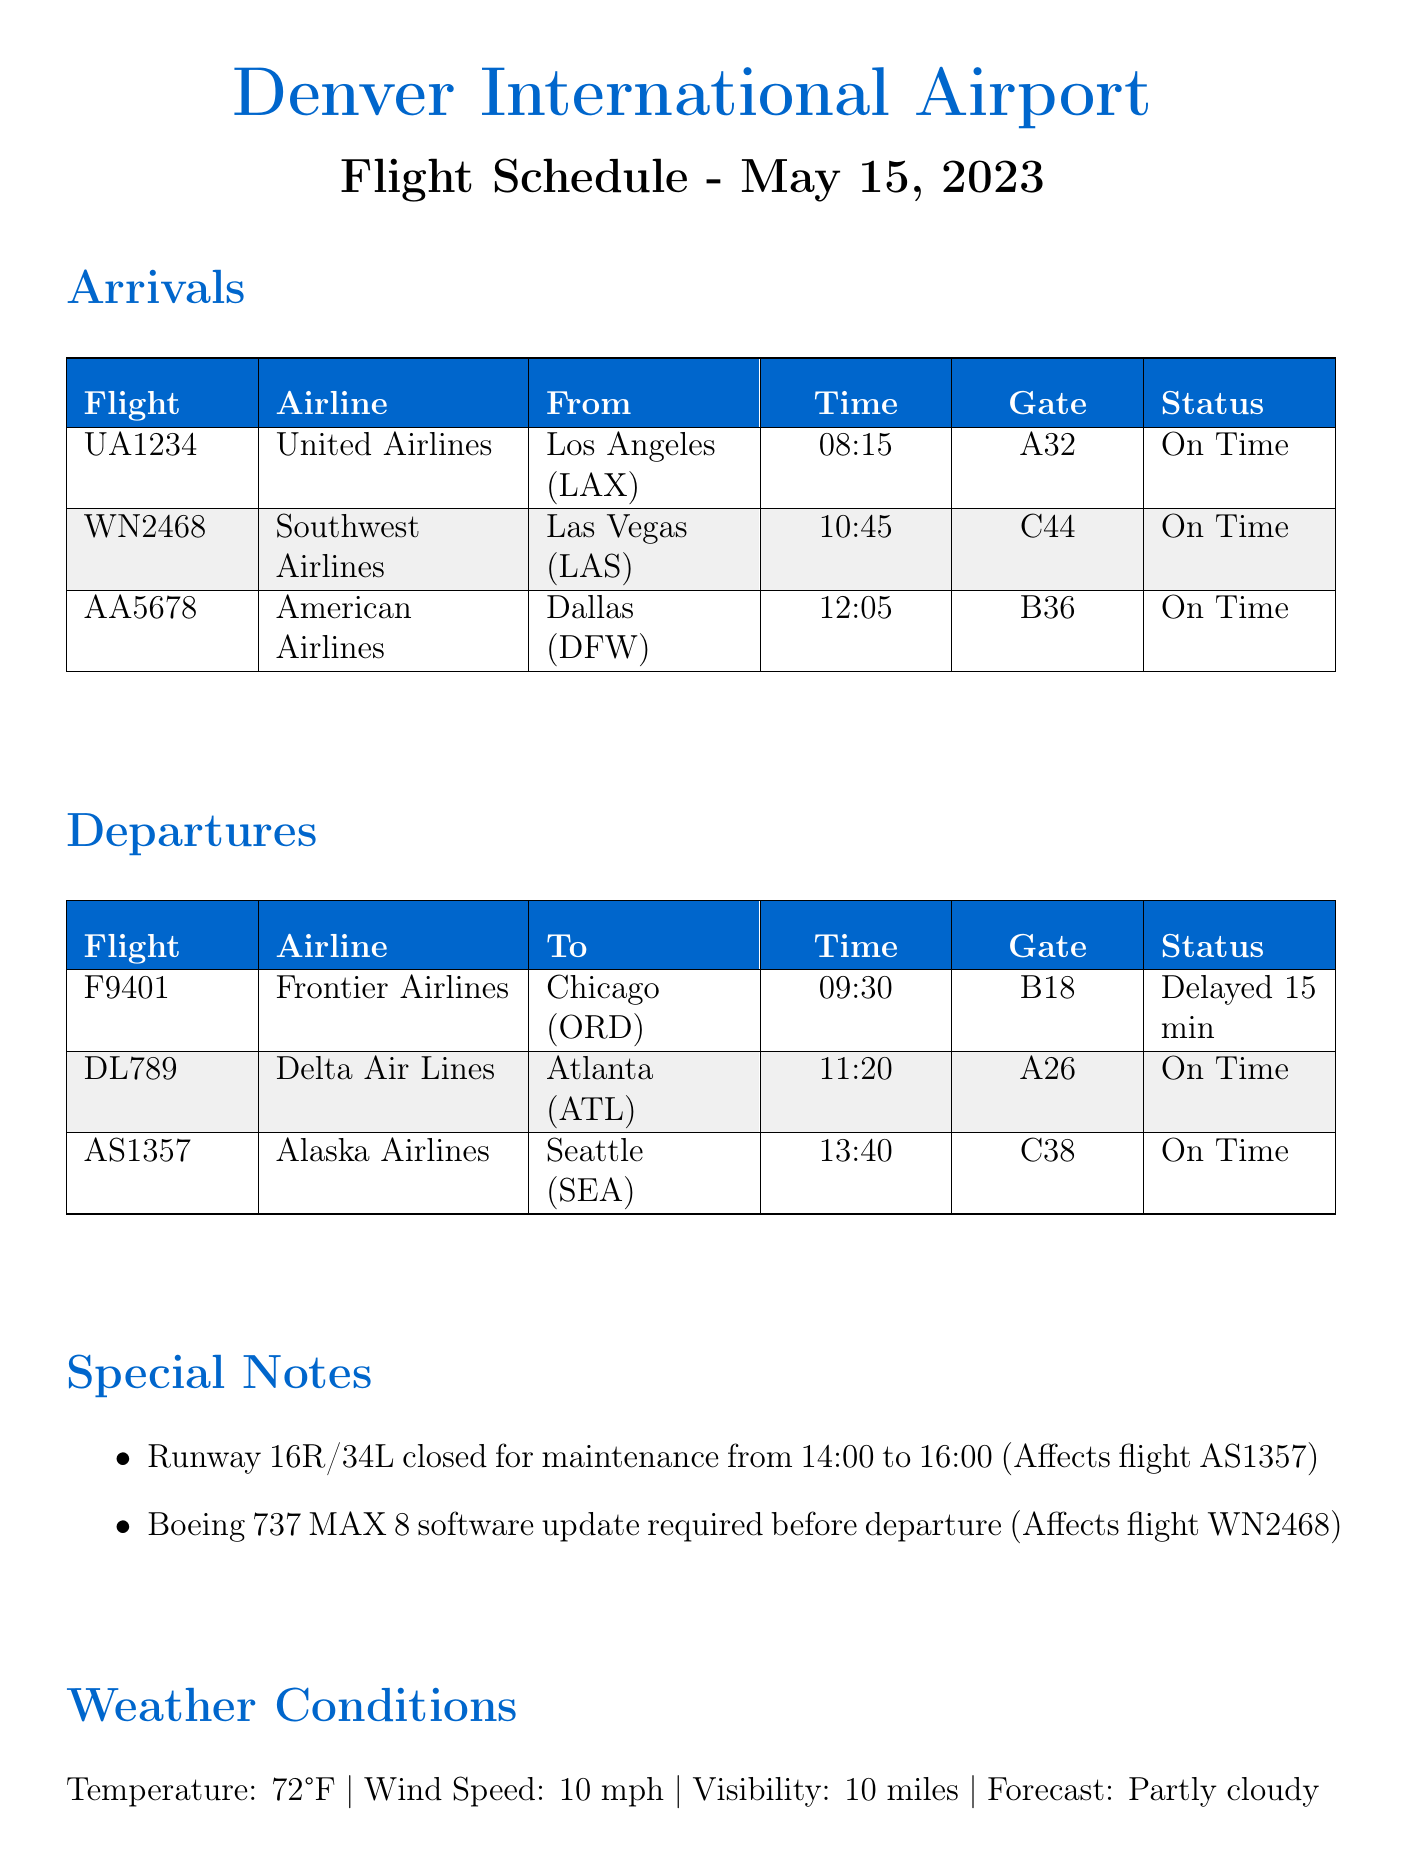What is the flight number of the Alaska Airlines flight? The flight number of the Alaska Airlines flight is found in the departures section, which indicates AS1357.
Answer: AS1357 What time is the estimated departure for Frontier Airlines? The estimated departure time for Frontier Airlines flight F9401 is listed in the departures section as 09:30.
Answer: 09:30 How many aircraft are listed in the arrivals section? The arrivals section lists three aircraft arriving at the airport, which are UA1234, WN2468, and AA5678.
Answer: 3 Which flight is delayed and by how many minutes? The document specifies that Frontier Airlines flight F9401 is delayed by 15 minutes.
Answer: 15 minutes Where is the United Club located? The location of the United Club is specified near gate B32 in the airport facilities section.
Answer: Concourse B, near gate B32 What special note affects flight AS1357? The special note indicates the runway 16R/34L is closed for maintenance from 14:00 to 16:00, affecting flight AS1357.
Answer: Runway 16R/34L closed for maintenance What is the status of the United Airlines flight UA1234? The status of United Airlines flight UA1234 is indicated as "On Time" in the arrivals section.
Answer: On Time What is the forecast for weather conditions? The weather forecast is noted as "Partly cloudy" in the weather conditions section of the document.
Answer: Partly cloudy What is the temperature at Denver International Airport? The temperature reported in the weather conditions section is 72°F.
Answer: 72°F 